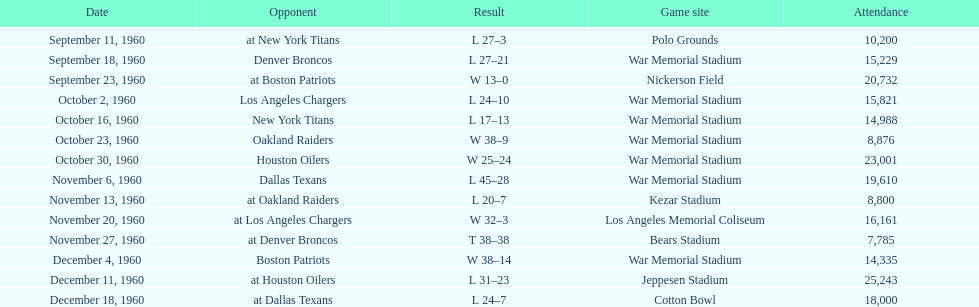In how many matches were there 10,000 or more attendees present? 11. 